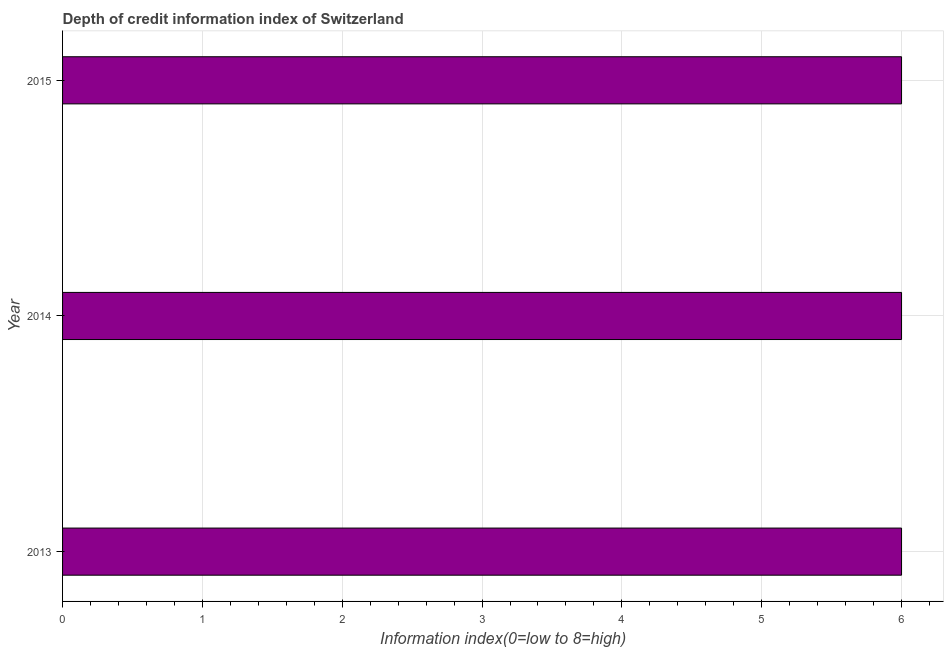Does the graph contain any zero values?
Keep it short and to the point. No. Does the graph contain grids?
Your response must be concise. Yes. What is the title of the graph?
Ensure brevity in your answer.  Depth of credit information index of Switzerland. What is the label or title of the X-axis?
Offer a terse response. Information index(0=low to 8=high). What is the depth of credit information index in 2015?
Give a very brief answer. 6. Across all years, what is the minimum depth of credit information index?
Give a very brief answer. 6. In which year was the depth of credit information index maximum?
Your response must be concise. 2013. What is the sum of the depth of credit information index?
Provide a short and direct response. 18. Is the sum of the depth of credit information index in 2013 and 2015 greater than the maximum depth of credit information index across all years?
Keep it short and to the point. Yes. In how many years, is the depth of credit information index greater than the average depth of credit information index taken over all years?
Your answer should be very brief. 0. How many bars are there?
Your response must be concise. 3. What is the difference between two consecutive major ticks on the X-axis?
Keep it short and to the point. 1. What is the Information index(0=low to 8=high) of 2013?
Offer a very short reply. 6. What is the Information index(0=low to 8=high) of 2015?
Provide a short and direct response. 6. What is the difference between the Information index(0=low to 8=high) in 2013 and 2014?
Give a very brief answer. 0. What is the difference between the Information index(0=low to 8=high) in 2014 and 2015?
Provide a succinct answer. 0. What is the ratio of the Information index(0=low to 8=high) in 2013 to that in 2014?
Ensure brevity in your answer.  1. 